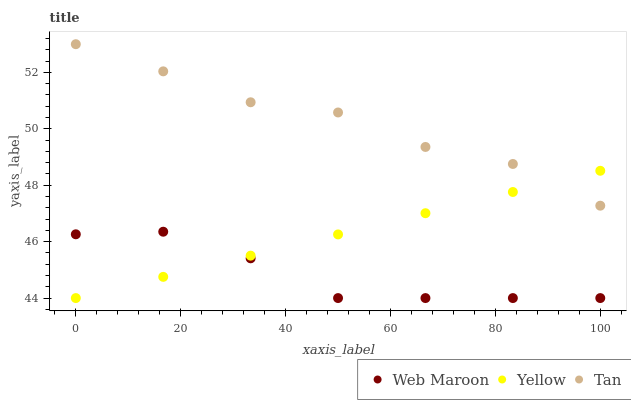Does Web Maroon have the minimum area under the curve?
Answer yes or no. Yes. Does Tan have the maximum area under the curve?
Answer yes or no. Yes. Does Yellow have the minimum area under the curve?
Answer yes or no. No. Does Yellow have the maximum area under the curve?
Answer yes or no. No. Is Yellow the smoothest?
Answer yes or no. Yes. Is Tan the roughest?
Answer yes or no. Yes. Is Web Maroon the smoothest?
Answer yes or no. No. Is Web Maroon the roughest?
Answer yes or no. No. Does Web Maroon have the lowest value?
Answer yes or no. Yes. Does Tan have the highest value?
Answer yes or no. Yes. Does Yellow have the highest value?
Answer yes or no. No. Is Web Maroon less than Tan?
Answer yes or no. Yes. Is Tan greater than Web Maroon?
Answer yes or no. Yes. Does Web Maroon intersect Yellow?
Answer yes or no. Yes. Is Web Maroon less than Yellow?
Answer yes or no. No. Is Web Maroon greater than Yellow?
Answer yes or no. No. Does Web Maroon intersect Tan?
Answer yes or no. No. 